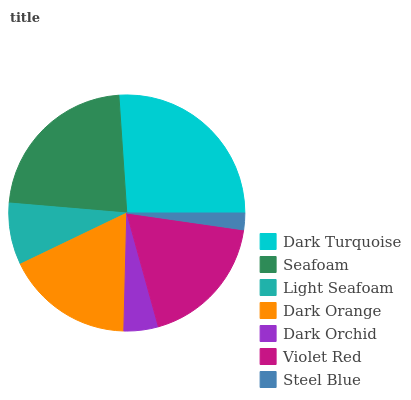Is Steel Blue the minimum?
Answer yes or no. Yes. Is Dark Turquoise the maximum?
Answer yes or no. Yes. Is Seafoam the minimum?
Answer yes or no. No. Is Seafoam the maximum?
Answer yes or no. No. Is Dark Turquoise greater than Seafoam?
Answer yes or no. Yes. Is Seafoam less than Dark Turquoise?
Answer yes or no. Yes. Is Seafoam greater than Dark Turquoise?
Answer yes or no. No. Is Dark Turquoise less than Seafoam?
Answer yes or no. No. Is Dark Orange the high median?
Answer yes or no. Yes. Is Dark Orange the low median?
Answer yes or no. Yes. Is Violet Red the high median?
Answer yes or no. No. Is Steel Blue the low median?
Answer yes or no. No. 